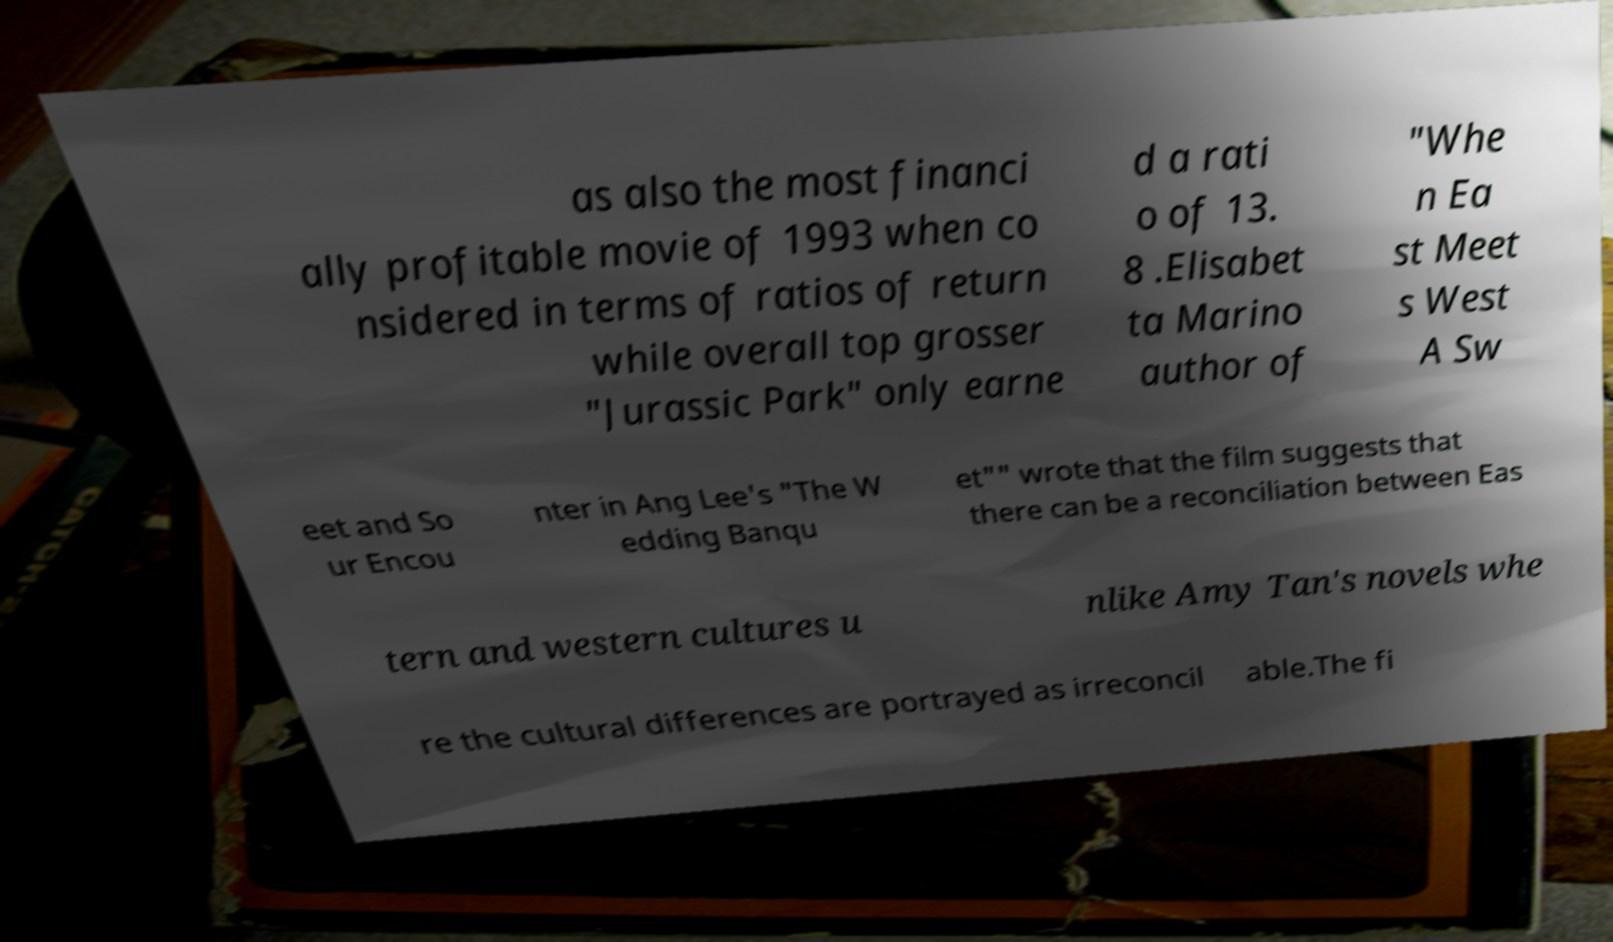Can you accurately transcribe the text from the provided image for me? as also the most financi ally profitable movie of 1993 when co nsidered in terms of ratios of return while overall top grosser "Jurassic Park" only earne d a rati o of 13. 8 .Elisabet ta Marino author of "Whe n Ea st Meet s West A Sw eet and So ur Encou nter in Ang Lee's "The W edding Banqu et"" wrote that the film suggests that there can be a reconciliation between Eas tern and western cultures u nlike Amy Tan's novels whe re the cultural differences are portrayed as irreconcil able.The fi 